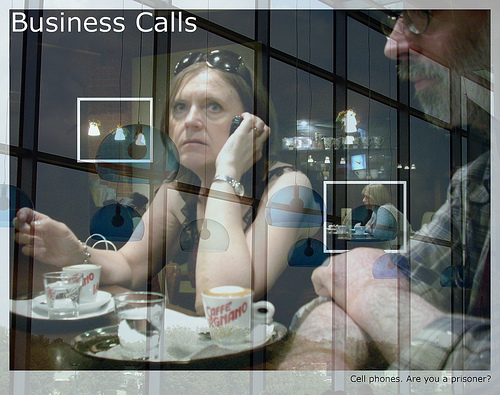What is the man wearing? The man is wearing glasses. 